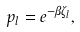Convert formula to latex. <formula><loc_0><loc_0><loc_500><loc_500>p _ { l } & = e ^ { - \beta \zeta _ { l } } ,</formula> 